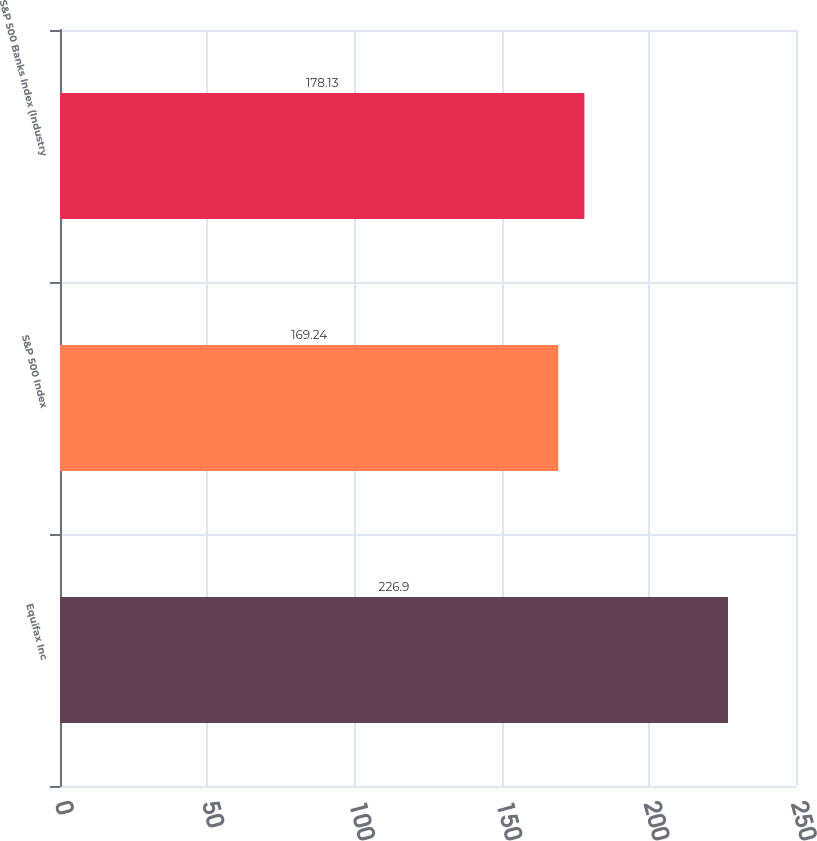<chart> <loc_0><loc_0><loc_500><loc_500><bar_chart><fcel>Equifax Inc<fcel>S&P 500 Index<fcel>S&P 500 Banks Index (Industry<nl><fcel>226.9<fcel>169.24<fcel>178.13<nl></chart> 